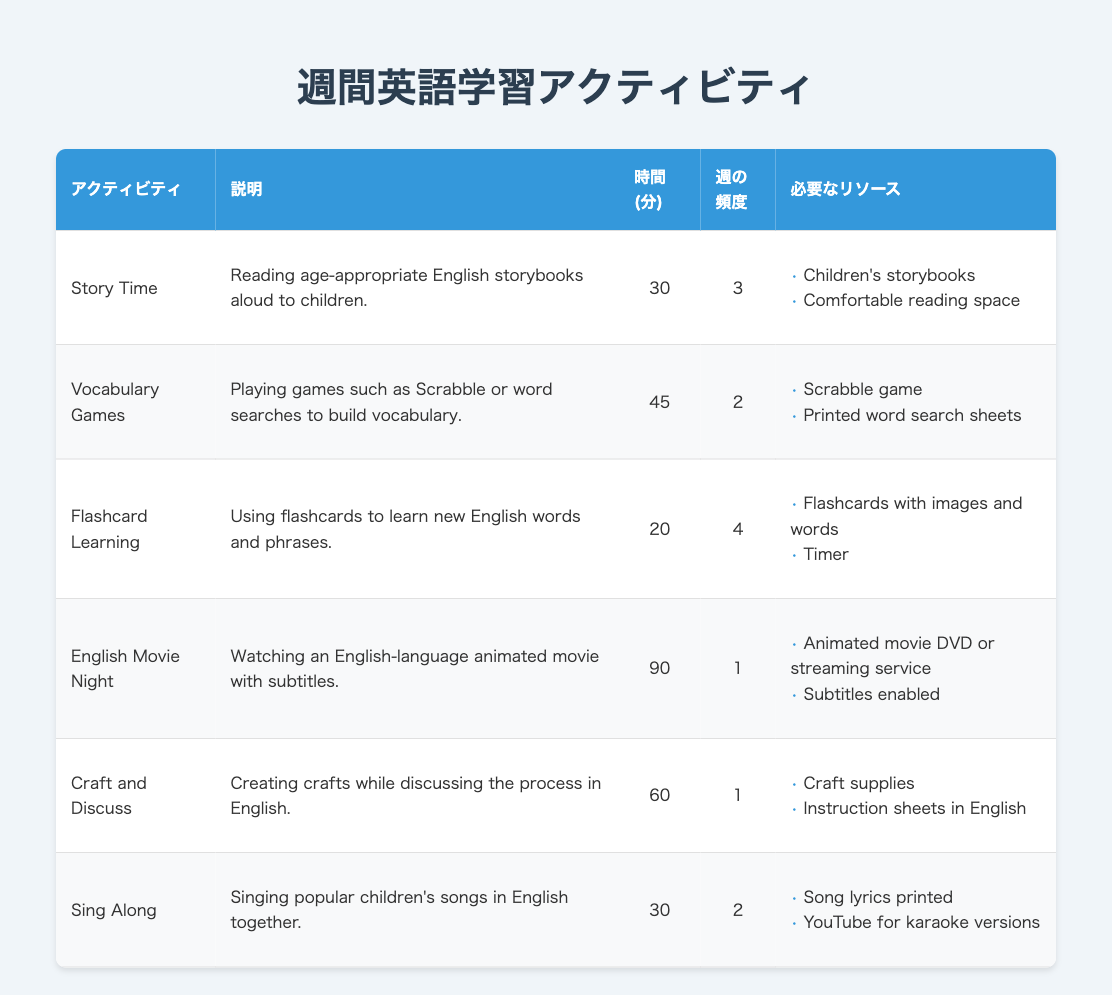What is the duration of the "Flashcard Learning" activity? The duration for the "Flashcard Learning" activity is directly listed in the table under the "時間 (分)" column. It is 20 minutes.
Answer: 20 minutes How many times per week do children participate in "Story Time"? The frequency of the "Story Time" activity is stated in the "週の頻度" column. It indicates that children participate in "Story Time" 3 times per week.
Answer: 3 times What resources are needed for the "Sing Along" activity? The resources for the "Sing Along" activity can be found in the "必要なリソース" column, which lists "Song lyrics printed" and "YouTube for karaoke versions."
Answer: Song lyrics printed, YouTube for karaoke versions Which activity has the longest duration? By comparing the "時間 (分)" column for all activities, "English Movie Night" has the longest duration of 90 minutes, which is more than any other activity listed.
Answer: English Movie Night What is the total duration (in minutes) spent on "Vocabulary Games" and "Craft and Discuss" activities combined? The duration for "Vocabulary Games" is 45 minutes, and for "Craft and Discuss," it is 60 minutes. Summing these gives 45 + 60 = 105 minutes of total duration for both activities combined.
Answer: 105 minutes Is "Flashcard Learning" done more often than "English Movie Night"? The frequency for "Flashcard Learning" is 4 times per week, and for "English Movie Night," it is only 1 time per week. Therefore, "Flashcard Learning" is done more often than "English Movie Night."
Answer: Yes How many total English learning activities have a duration of 30 minutes? Referring to the table, there are 2 activities with a duration of 30 minutes: "Story Time" and "Sing Along." Thus, the total is 2 activities.
Answer: 2 activities What is the average duration of the activities listed? To find the average, sum the durations: 30 (Story Time) + 45 (Vocabulary Games) + 20 (Flashcard Learning) + 90 (English Movie Night) + 60 (Craft and Discuss) + 30 (Sing Along) = 275 minutes, and then divide by the number of activities (6). So, the average is 275/6 = 45.83 minutes.
Answer: 45.83 minutes What is the frequency of "Craft and Discuss"? By checking the "週の頻度" column, the frequency for "Craft and Discuss" is listed as 1 per week.
Answer: 1 time per week 